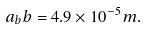<formula> <loc_0><loc_0><loc_500><loc_500>a _ { b } b = 4 . 9 \times 1 0 ^ { - 5 } m .</formula> 